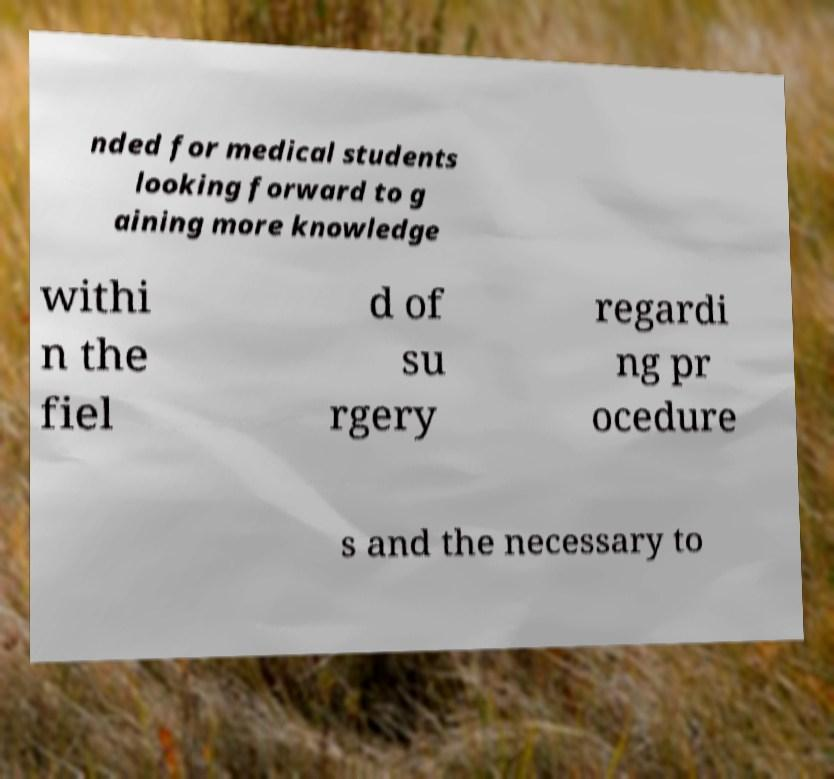For documentation purposes, I need the text within this image transcribed. Could you provide that? nded for medical students looking forward to g aining more knowledge withi n the fiel d of su rgery regardi ng pr ocedure s and the necessary to 